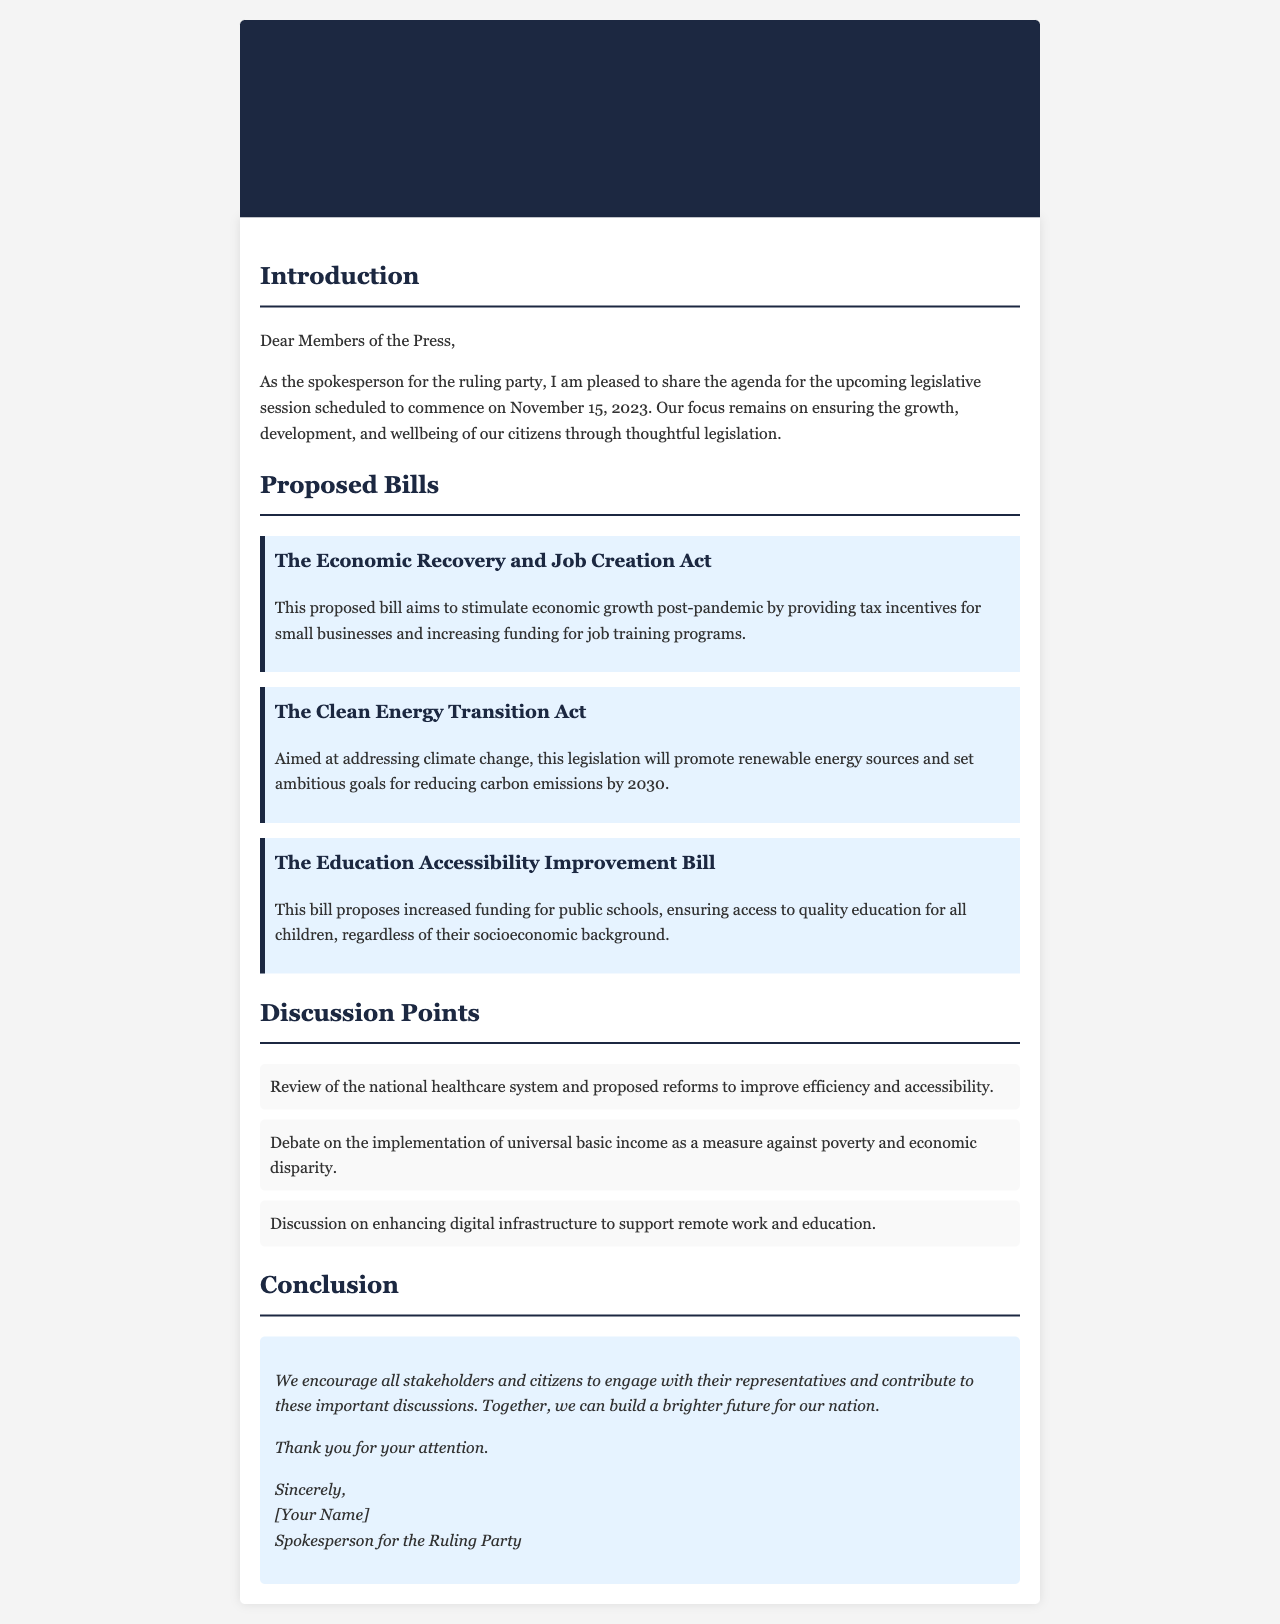What is the date of the upcoming legislative session? The document specifies that the legislative session is scheduled to commence on November 15, 2023.
Answer: November 15, 2023 What is the title of the first proposed bill? The first proposed bill mentioned in the document is titled "The Economic Recovery and Job Creation Act".
Answer: The Economic Recovery and Job Creation Act What is a goal of The Clean Energy Transition Act? The document states that this legislation aims to promote renewable energy sources and set ambitious goals for reducing carbon emissions by 2030.
Answer: Reducing carbon emissions by 2030 How many proposed bills are listed in the document? The document details three proposed bills: The Economic Recovery and Job Creation Act, The Clean Energy Transition Act, and The Education Accessibility Improvement Bill.
Answer: Three What is the central theme of the "Education Accessibility Improvement Bill"? The document explains that this bill proposes increased funding for public schools to ensure access to quality education for all children.
Answer: Increased funding for public schools What topic is being reviewed as a discussion point? The document lists the review of the national healthcare system and proposed reforms to improve efficiency and accessibility as a discussion point.
Answer: National healthcare system How does the document encourage public engagement? The conclusion urges stakeholders and citizens to engage with their representatives and contribute to the important discussions surrounding legislation.
Answer: Engage with their representatives What type of infrastructure is discussed for enhancement? The document mentions enhancing digital infrastructure to support remote work and education as a discussion point.
Answer: Digital infrastructure 